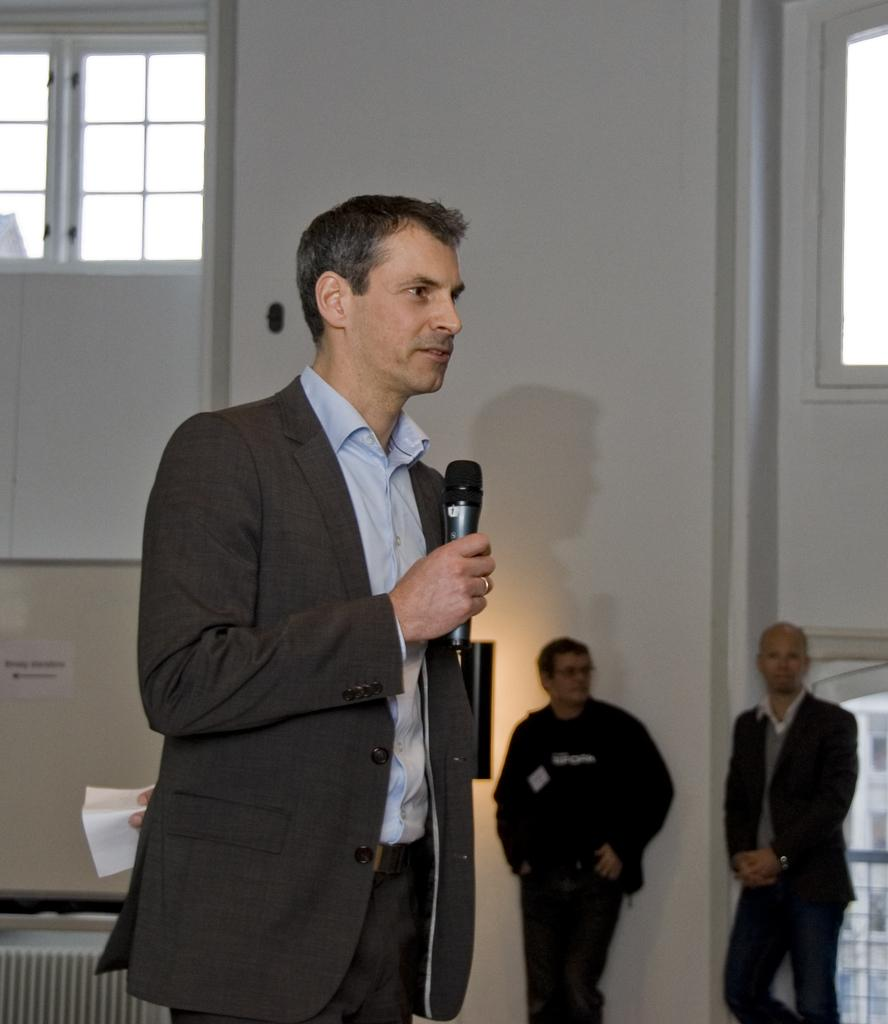How many people are in the image? There are three persons standing in the image. What is one of the persons holding? One of the persons is holding a microphone. What can be seen in the background of the image? There is a wall and a window in the background of the image. Are there any plants visible in the image? There is no mention of plants in the provided facts, so we cannot determine if any are visible in the image. 